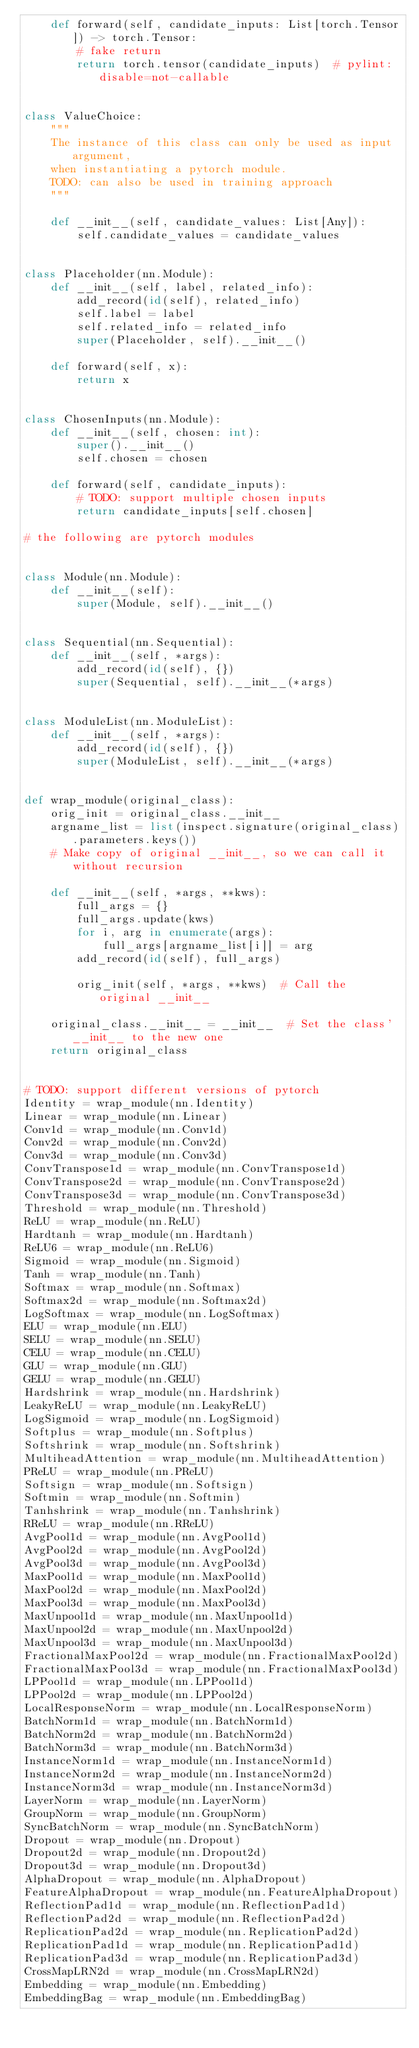Convert code to text. <code><loc_0><loc_0><loc_500><loc_500><_Python_>    def forward(self, candidate_inputs: List[torch.Tensor]) -> torch.Tensor:
        # fake return
        return torch.tensor(candidate_inputs)  # pylint: disable=not-callable


class ValueChoice:
    """
    The instance of this class can only be used as input argument,
    when instantiating a pytorch module.
    TODO: can also be used in training approach
    """

    def __init__(self, candidate_values: List[Any]):
        self.candidate_values = candidate_values


class Placeholder(nn.Module):
    def __init__(self, label, related_info):
        add_record(id(self), related_info)
        self.label = label
        self.related_info = related_info
        super(Placeholder, self).__init__()

    def forward(self, x):
        return x


class ChosenInputs(nn.Module):
    def __init__(self, chosen: int):
        super().__init__()
        self.chosen = chosen

    def forward(self, candidate_inputs):
        # TODO: support multiple chosen inputs
        return candidate_inputs[self.chosen]

# the following are pytorch modules


class Module(nn.Module):
    def __init__(self):
        super(Module, self).__init__()


class Sequential(nn.Sequential):
    def __init__(self, *args):
        add_record(id(self), {})
        super(Sequential, self).__init__(*args)


class ModuleList(nn.ModuleList):
    def __init__(self, *args):
        add_record(id(self), {})
        super(ModuleList, self).__init__(*args)


def wrap_module(original_class):
    orig_init = original_class.__init__
    argname_list = list(inspect.signature(original_class).parameters.keys())
    # Make copy of original __init__, so we can call it without recursion

    def __init__(self, *args, **kws):
        full_args = {}
        full_args.update(kws)
        for i, arg in enumerate(args):
            full_args[argname_list[i]] = arg
        add_record(id(self), full_args)

        orig_init(self, *args, **kws)  # Call the original __init__

    original_class.__init__ = __init__  # Set the class' __init__ to the new one
    return original_class


# TODO: support different versions of pytorch
Identity = wrap_module(nn.Identity)
Linear = wrap_module(nn.Linear)
Conv1d = wrap_module(nn.Conv1d)
Conv2d = wrap_module(nn.Conv2d)
Conv3d = wrap_module(nn.Conv3d)
ConvTranspose1d = wrap_module(nn.ConvTranspose1d)
ConvTranspose2d = wrap_module(nn.ConvTranspose2d)
ConvTranspose3d = wrap_module(nn.ConvTranspose3d)
Threshold = wrap_module(nn.Threshold)
ReLU = wrap_module(nn.ReLU)
Hardtanh = wrap_module(nn.Hardtanh)
ReLU6 = wrap_module(nn.ReLU6)
Sigmoid = wrap_module(nn.Sigmoid)
Tanh = wrap_module(nn.Tanh)
Softmax = wrap_module(nn.Softmax)
Softmax2d = wrap_module(nn.Softmax2d)
LogSoftmax = wrap_module(nn.LogSoftmax)
ELU = wrap_module(nn.ELU)
SELU = wrap_module(nn.SELU)
CELU = wrap_module(nn.CELU)
GLU = wrap_module(nn.GLU)
GELU = wrap_module(nn.GELU)
Hardshrink = wrap_module(nn.Hardshrink)
LeakyReLU = wrap_module(nn.LeakyReLU)
LogSigmoid = wrap_module(nn.LogSigmoid)
Softplus = wrap_module(nn.Softplus)
Softshrink = wrap_module(nn.Softshrink)
MultiheadAttention = wrap_module(nn.MultiheadAttention)
PReLU = wrap_module(nn.PReLU)
Softsign = wrap_module(nn.Softsign)
Softmin = wrap_module(nn.Softmin)
Tanhshrink = wrap_module(nn.Tanhshrink)
RReLU = wrap_module(nn.RReLU)
AvgPool1d = wrap_module(nn.AvgPool1d)
AvgPool2d = wrap_module(nn.AvgPool2d)
AvgPool3d = wrap_module(nn.AvgPool3d)
MaxPool1d = wrap_module(nn.MaxPool1d)
MaxPool2d = wrap_module(nn.MaxPool2d)
MaxPool3d = wrap_module(nn.MaxPool3d)
MaxUnpool1d = wrap_module(nn.MaxUnpool1d)
MaxUnpool2d = wrap_module(nn.MaxUnpool2d)
MaxUnpool3d = wrap_module(nn.MaxUnpool3d)
FractionalMaxPool2d = wrap_module(nn.FractionalMaxPool2d)
FractionalMaxPool3d = wrap_module(nn.FractionalMaxPool3d)
LPPool1d = wrap_module(nn.LPPool1d)
LPPool2d = wrap_module(nn.LPPool2d)
LocalResponseNorm = wrap_module(nn.LocalResponseNorm)
BatchNorm1d = wrap_module(nn.BatchNorm1d)
BatchNorm2d = wrap_module(nn.BatchNorm2d)
BatchNorm3d = wrap_module(nn.BatchNorm3d)
InstanceNorm1d = wrap_module(nn.InstanceNorm1d)
InstanceNorm2d = wrap_module(nn.InstanceNorm2d)
InstanceNorm3d = wrap_module(nn.InstanceNorm3d)
LayerNorm = wrap_module(nn.LayerNorm)
GroupNorm = wrap_module(nn.GroupNorm)
SyncBatchNorm = wrap_module(nn.SyncBatchNorm)
Dropout = wrap_module(nn.Dropout)
Dropout2d = wrap_module(nn.Dropout2d)
Dropout3d = wrap_module(nn.Dropout3d)
AlphaDropout = wrap_module(nn.AlphaDropout)
FeatureAlphaDropout = wrap_module(nn.FeatureAlphaDropout)
ReflectionPad1d = wrap_module(nn.ReflectionPad1d)
ReflectionPad2d = wrap_module(nn.ReflectionPad2d)
ReplicationPad2d = wrap_module(nn.ReplicationPad2d)
ReplicationPad1d = wrap_module(nn.ReplicationPad1d)
ReplicationPad3d = wrap_module(nn.ReplicationPad3d)
CrossMapLRN2d = wrap_module(nn.CrossMapLRN2d)
Embedding = wrap_module(nn.Embedding)
EmbeddingBag = wrap_module(nn.EmbeddingBag)</code> 